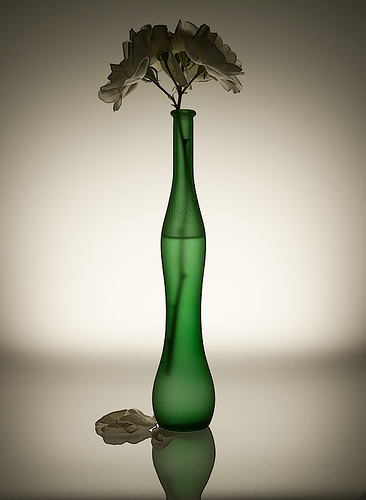<image>How many flowers are in the vase? I don't know the exact number of flowers in the vase, it could be 1,2, 3 or 4. What fruit is the drink in the glass made out of? I don't know what fruit the drink in the glass is made out of. It could be lemon, lime, dragon fruit or pear. Whose face is that? There is no face in the image. How many flowers are in the vase? I don't know how many flowers are in the vase. It can be 3, 4, 2 or 1. Whose face is that? I don't know whose face it is. There doesn't seem to be any face in the image. What fruit is the drink in the glass made out of? I don't know what fruit the drink in the glass is made out of. There are options like 'dragon fruit', 'pear', 'lemon', or 'lime'. 